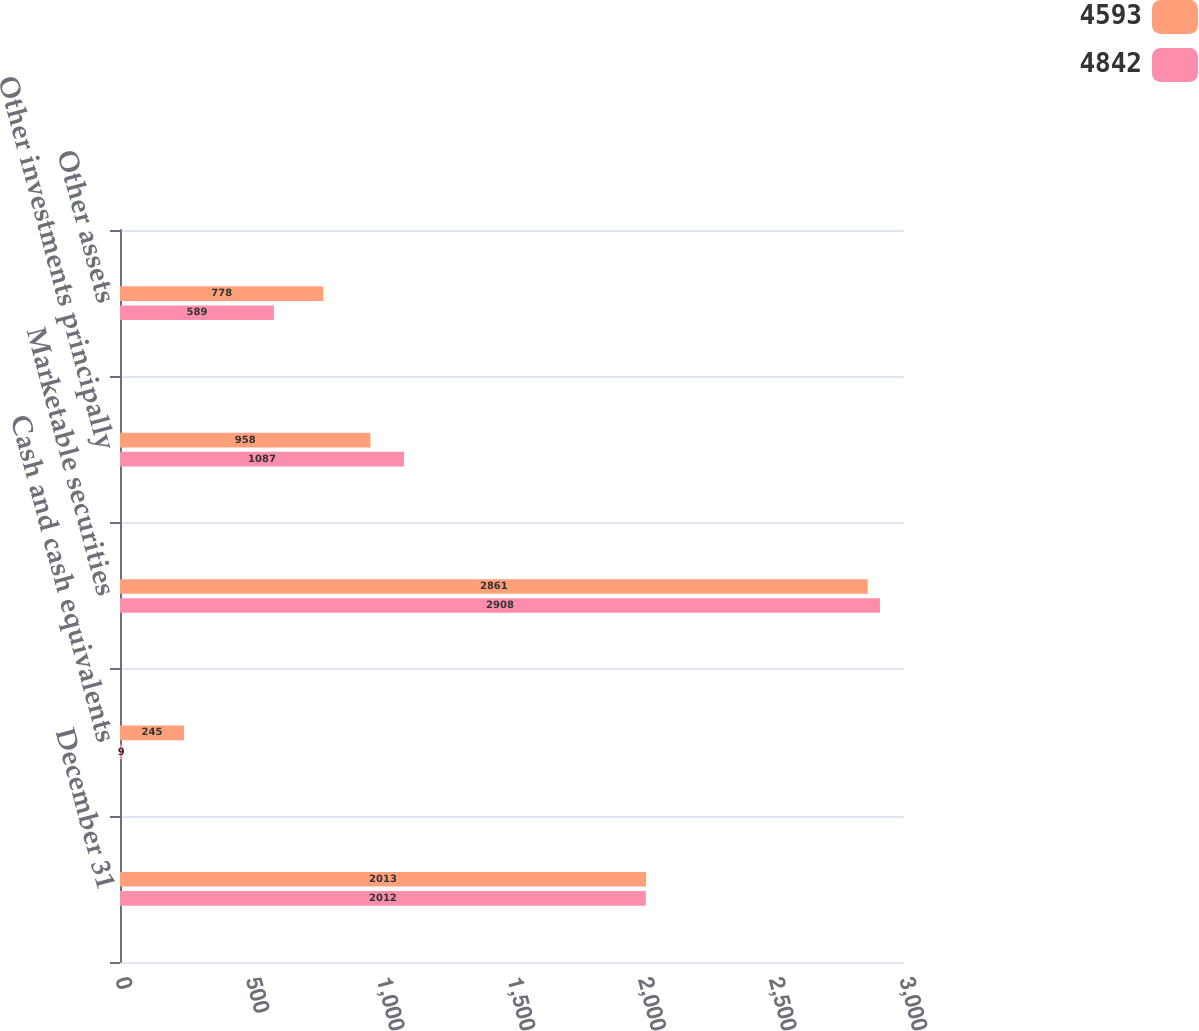Convert chart to OTSL. <chart><loc_0><loc_0><loc_500><loc_500><stacked_bar_chart><ecel><fcel>December 31<fcel>Cash and cash equivalents<fcel>Marketable securities<fcel>Other investments principally<fcel>Other assets<nl><fcel>4593<fcel>2013<fcel>245<fcel>2861<fcel>958<fcel>778<nl><fcel>4842<fcel>2012<fcel>9<fcel>2908<fcel>1087<fcel>589<nl></chart> 